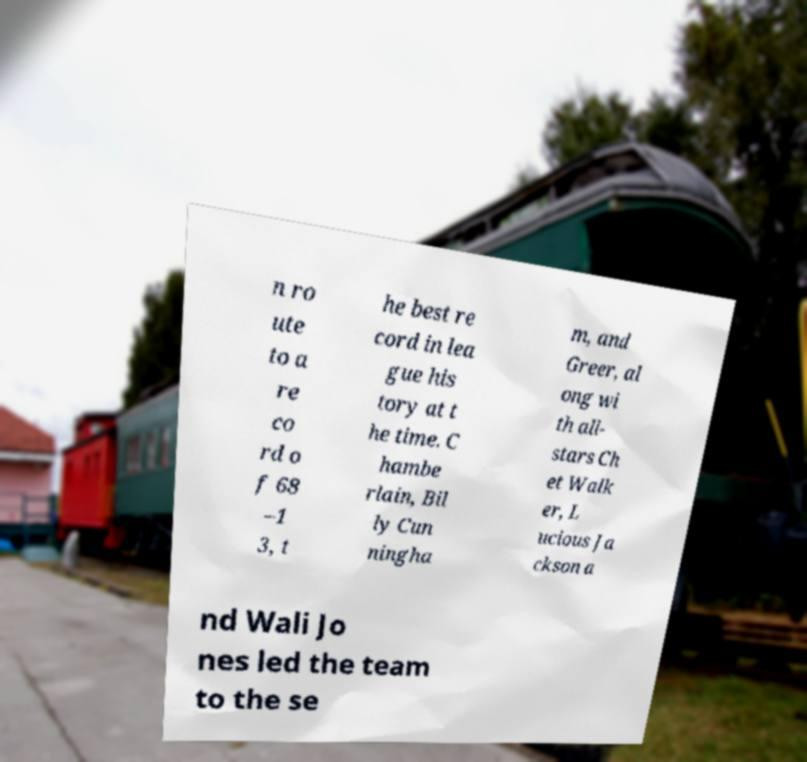Please read and relay the text visible in this image. What does it say? n ro ute to a re co rd o f 68 –1 3, t he best re cord in lea gue his tory at t he time. C hambe rlain, Bil ly Cun ningha m, and Greer, al ong wi th all- stars Ch et Walk er, L ucious Ja ckson a nd Wali Jo nes led the team to the se 